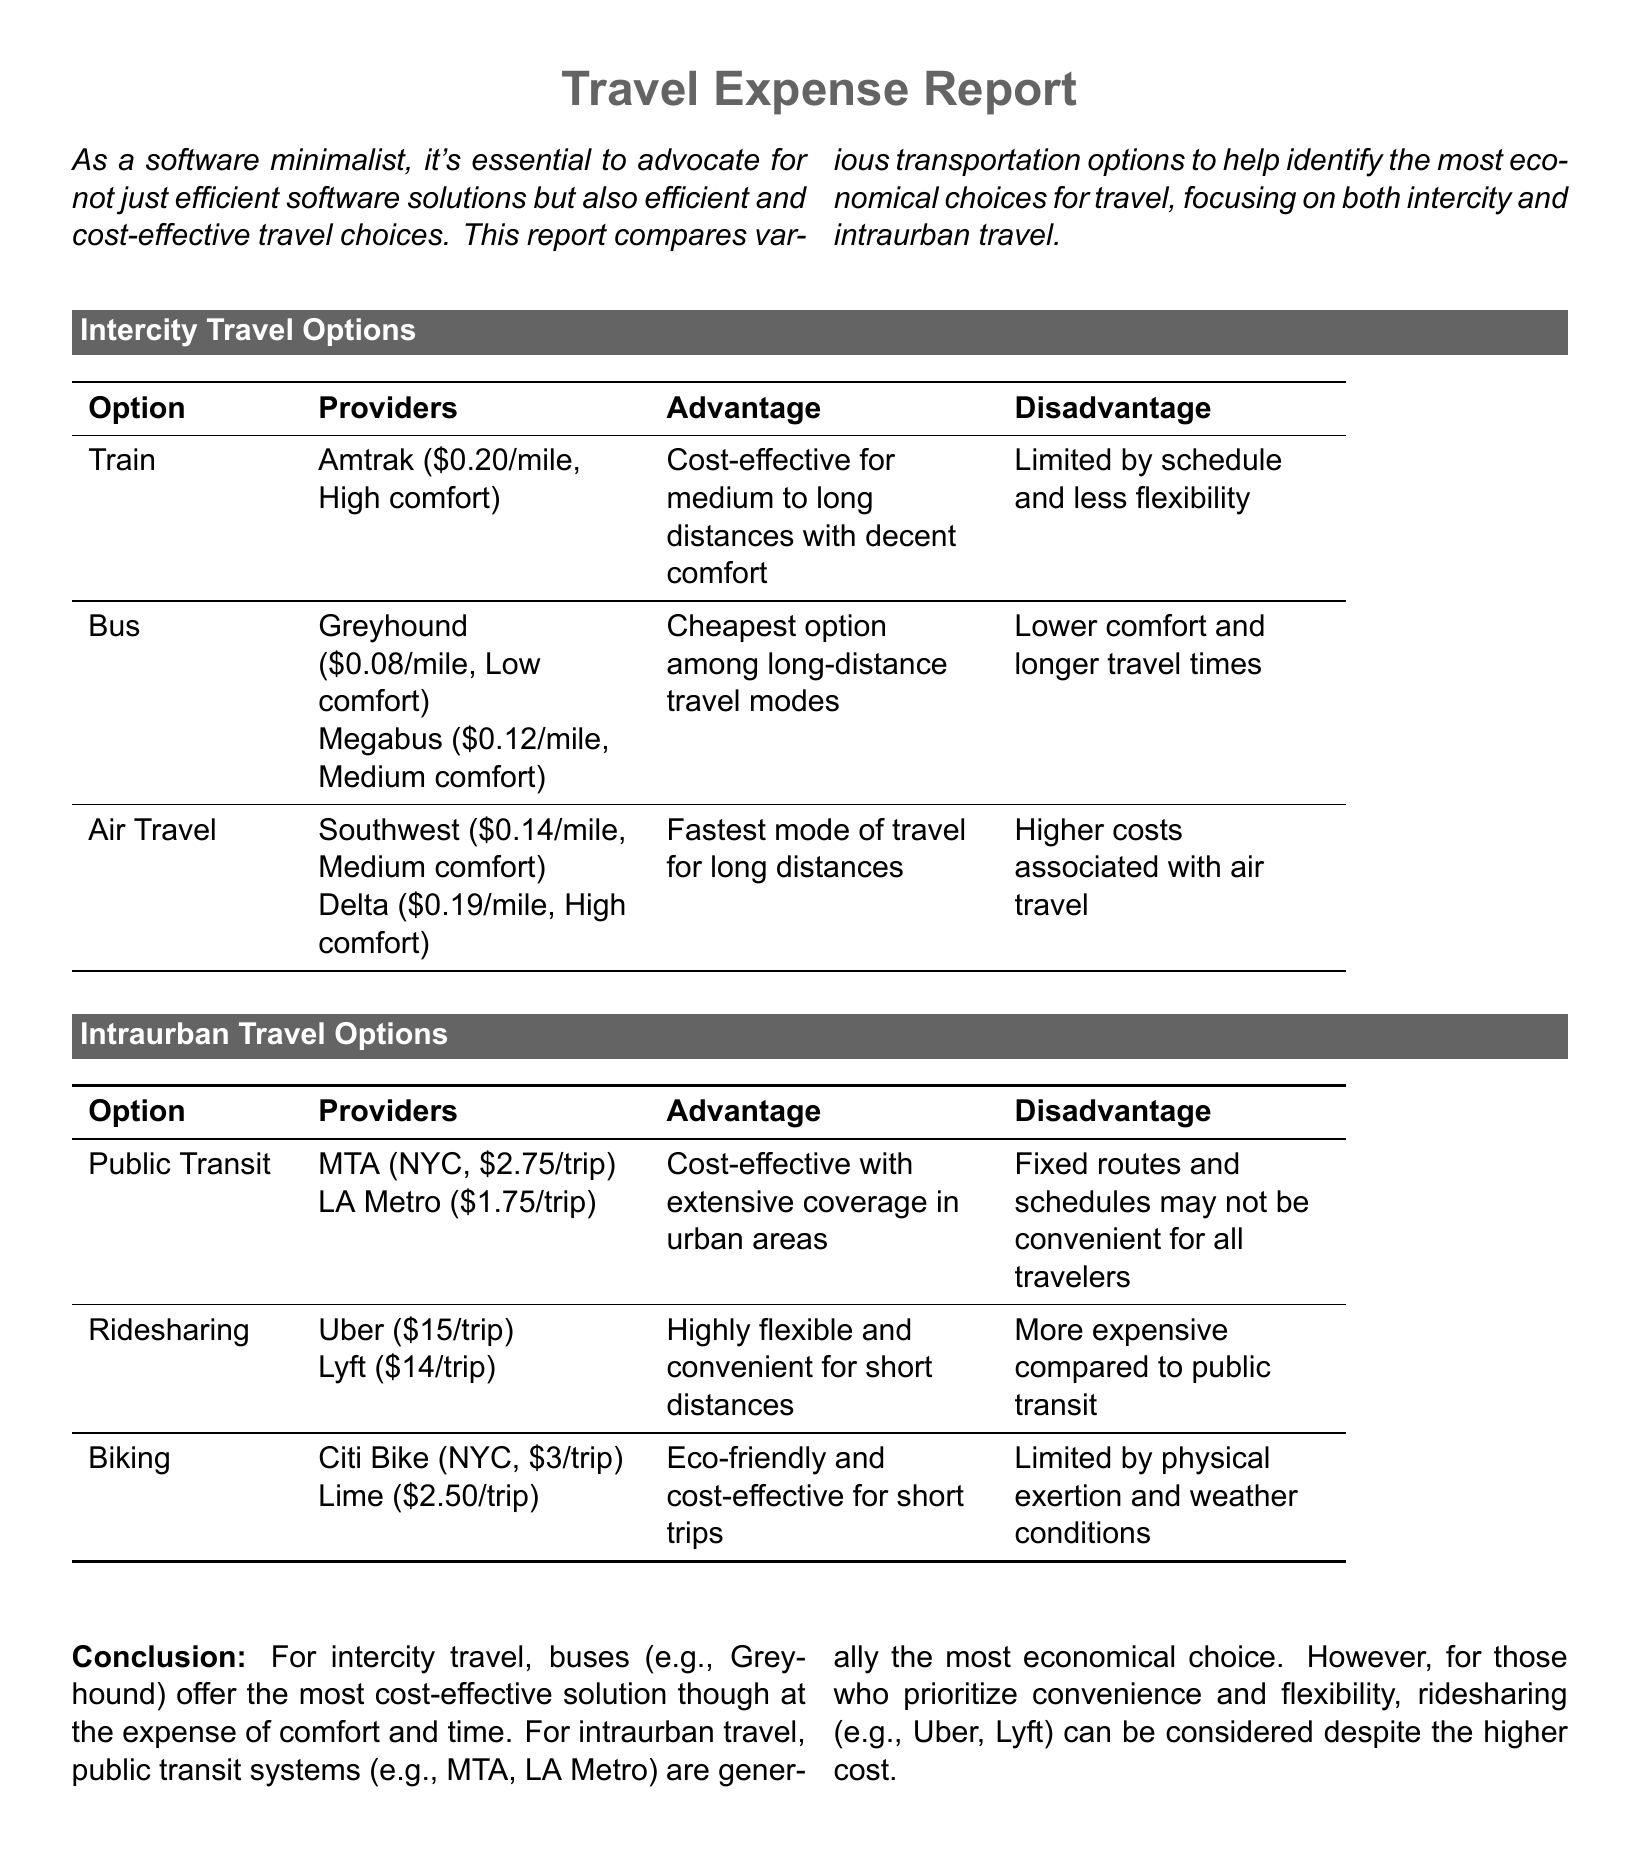What is the cost per mile for bus travel with Megabus? The cost per mile for Megabus is stated as $0.12/mile.
Answer: $0.12/mile Which transportation option has the highest comfort level? The table lists Delta air travel as having high comfort.
Answer: Delta What is the fare for a trip on LA Metro? The document specifies that the fare for LA Metro is $1.75/trip.
Answer: $1.75/trip What is the disadvantage of using public transit? The document mentions that fixed routes and schedules may not be convenient.
Answer: Fixed routes and schedules Which intercity travel option is the cheapest? Bus travel, specifically Greyhound, is identified as the cheapest option.
Answer: Greyhound How much does a trip on Citi Bike in NYC cost? The document states the cost for a Citi Bike trip is $3/trip.
Answer: $3/trip What is the advantage of choosing train travel? The advantage of train travel is that it is cost-effective for medium to long distances with decent comfort.
Answer: Cost-effective for medium to long distances Which transportation option is identified as eco-friendly? The report specifies biking as the eco-friendly option for travel.
Answer: Biking What type of document is this? The document is identified as a Travel Expense Report.
Answer: Travel Expense Report 